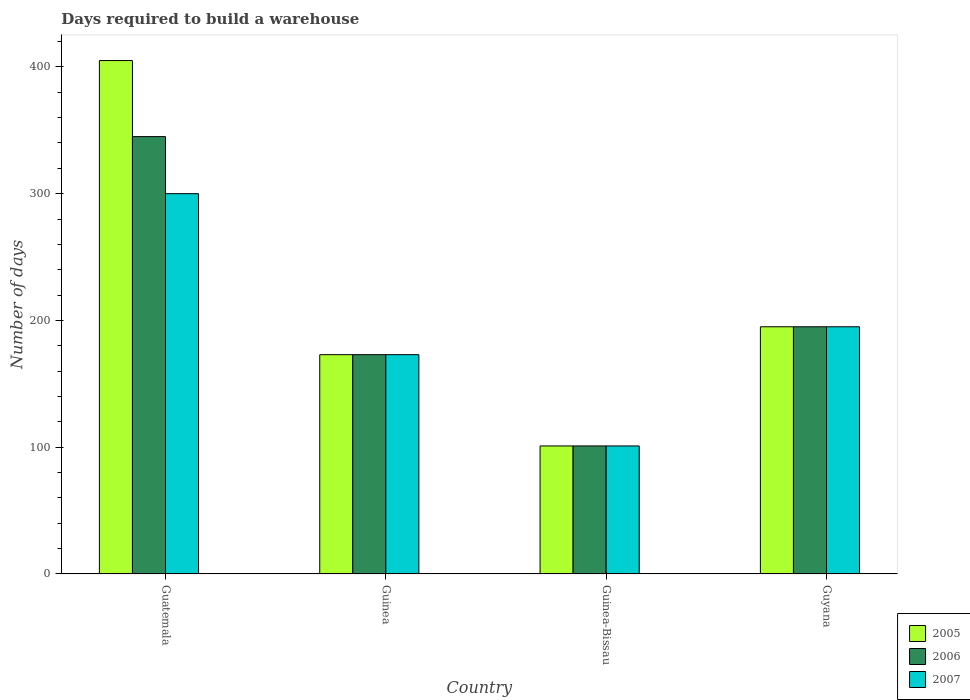How many groups of bars are there?
Keep it short and to the point. 4. Are the number of bars per tick equal to the number of legend labels?
Your answer should be very brief. Yes. Are the number of bars on each tick of the X-axis equal?
Keep it short and to the point. Yes. What is the label of the 3rd group of bars from the left?
Offer a very short reply. Guinea-Bissau. In how many cases, is the number of bars for a given country not equal to the number of legend labels?
Ensure brevity in your answer.  0. What is the days required to build a warehouse in in 2006 in Guinea-Bissau?
Make the answer very short. 101. Across all countries, what is the maximum days required to build a warehouse in in 2007?
Give a very brief answer. 300. Across all countries, what is the minimum days required to build a warehouse in in 2007?
Provide a succinct answer. 101. In which country was the days required to build a warehouse in in 2006 maximum?
Your response must be concise. Guatemala. In which country was the days required to build a warehouse in in 2005 minimum?
Give a very brief answer. Guinea-Bissau. What is the total days required to build a warehouse in in 2006 in the graph?
Offer a terse response. 814. What is the difference between the days required to build a warehouse in in 2005 in Guinea-Bissau and that in Guyana?
Provide a succinct answer. -94. What is the difference between the days required to build a warehouse in in 2007 in Guinea and the days required to build a warehouse in in 2005 in Guinea-Bissau?
Give a very brief answer. 72. What is the average days required to build a warehouse in in 2006 per country?
Provide a succinct answer. 203.5. What is the difference between the days required to build a warehouse in of/in 2006 and days required to build a warehouse in of/in 2007 in Guyana?
Make the answer very short. 0. In how many countries, is the days required to build a warehouse in in 2007 greater than 40 days?
Your answer should be very brief. 4. What is the ratio of the days required to build a warehouse in in 2005 in Guatemala to that in Guyana?
Give a very brief answer. 2.08. Is the days required to build a warehouse in in 2006 in Guatemala less than that in Guyana?
Give a very brief answer. No. What is the difference between the highest and the second highest days required to build a warehouse in in 2006?
Provide a short and direct response. 150. What is the difference between the highest and the lowest days required to build a warehouse in in 2006?
Make the answer very short. 244. Is it the case that in every country, the sum of the days required to build a warehouse in in 2007 and days required to build a warehouse in in 2005 is greater than the days required to build a warehouse in in 2006?
Provide a short and direct response. Yes. Are all the bars in the graph horizontal?
Ensure brevity in your answer.  No. How many countries are there in the graph?
Keep it short and to the point. 4. Where does the legend appear in the graph?
Your answer should be very brief. Bottom right. What is the title of the graph?
Your answer should be compact. Days required to build a warehouse. What is the label or title of the X-axis?
Your answer should be compact. Country. What is the label or title of the Y-axis?
Ensure brevity in your answer.  Number of days. What is the Number of days of 2005 in Guatemala?
Provide a short and direct response. 405. What is the Number of days of 2006 in Guatemala?
Provide a succinct answer. 345. What is the Number of days in 2007 in Guatemala?
Give a very brief answer. 300. What is the Number of days in 2005 in Guinea?
Make the answer very short. 173. What is the Number of days of 2006 in Guinea?
Provide a succinct answer. 173. What is the Number of days of 2007 in Guinea?
Keep it short and to the point. 173. What is the Number of days in 2005 in Guinea-Bissau?
Your response must be concise. 101. What is the Number of days in 2006 in Guinea-Bissau?
Your answer should be very brief. 101. What is the Number of days in 2007 in Guinea-Bissau?
Keep it short and to the point. 101. What is the Number of days in 2005 in Guyana?
Ensure brevity in your answer.  195. What is the Number of days in 2006 in Guyana?
Your answer should be compact. 195. What is the Number of days of 2007 in Guyana?
Your response must be concise. 195. Across all countries, what is the maximum Number of days in 2005?
Make the answer very short. 405. Across all countries, what is the maximum Number of days of 2006?
Make the answer very short. 345. Across all countries, what is the maximum Number of days of 2007?
Your answer should be very brief. 300. Across all countries, what is the minimum Number of days in 2005?
Give a very brief answer. 101. Across all countries, what is the minimum Number of days in 2006?
Your answer should be very brief. 101. Across all countries, what is the minimum Number of days of 2007?
Give a very brief answer. 101. What is the total Number of days of 2005 in the graph?
Give a very brief answer. 874. What is the total Number of days in 2006 in the graph?
Give a very brief answer. 814. What is the total Number of days of 2007 in the graph?
Offer a terse response. 769. What is the difference between the Number of days of 2005 in Guatemala and that in Guinea?
Keep it short and to the point. 232. What is the difference between the Number of days in 2006 in Guatemala and that in Guinea?
Give a very brief answer. 172. What is the difference between the Number of days of 2007 in Guatemala and that in Guinea?
Offer a terse response. 127. What is the difference between the Number of days of 2005 in Guatemala and that in Guinea-Bissau?
Offer a very short reply. 304. What is the difference between the Number of days in 2006 in Guatemala and that in Guinea-Bissau?
Your response must be concise. 244. What is the difference between the Number of days of 2007 in Guatemala and that in Guinea-Bissau?
Ensure brevity in your answer.  199. What is the difference between the Number of days in 2005 in Guatemala and that in Guyana?
Your response must be concise. 210. What is the difference between the Number of days in 2006 in Guatemala and that in Guyana?
Your answer should be very brief. 150. What is the difference between the Number of days in 2007 in Guatemala and that in Guyana?
Ensure brevity in your answer.  105. What is the difference between the Number of days in 2005 in Guinea and that in Guinea-Bissau?
Keep it short and to the point. 72. What is the difference between the Number of days of 2007 in Guinea and that in Guinea-Bissau?
Offer a very short reply. 72. What is the difference between the Number of days in 2005 in Guinea and that in Guyana?
Offer a very short reply. -22. What is the difference between the Number of days in 2005 in Guinea-Bissau and that in Guyana?
Provide a succinct answer. -94. What is the difference between the Number of days in 2006 in Guinea-Bissau and that in Guyana?
Give a very brief answer. -94. What is the difference between the Number of days in 2007 in Guinea-Bissau and that in Guyana?
Give a very brief answer. -94. What is the difference between the Number of days of 2005 in Guatemala and the Number of days of 2006 in Guinea?
Provide a short and direct response. 232. What is the difference between the Number of days of 2005 in Guatemala and the Number of days of 2007 in Guinea?
Your answer should be very brief. 232. What is the difference between the Number of days of 2006 in Guatemala and the Number of days of 2007 in Guinea?
Make the answer very short. 172. What is the difference between the Number of days in 2005 in Guatemala and the Number of days in 2006 in Guinea-Bissau?
Ensure brevity in your answer.  304. What is the difference between the Number of days of 2005 in Guatemala and the Number of days of 2007 in Guinea-Bissau?
Make the answer very short. 304. What is the difference between the Number of days in 2006 in Guatemala and the Number of days in 2007 in Guinea-Bissau?
Provide a short and direct response. 244. What is the difference between the Number of days of 2005 in Guatemala and the Number of days of 2006 in Guyana?
Give a very brief answer. 210. What is the difference between the Number of days in 2005 in Guatemala and the Number of days in 2007 in Guyana?
Provide a succinct answer. 210. What is the difference between the Number of days in 2006 in Guatemala and the Number of days in 2007 in Guyana?
Offer a terse response. 150. What is the difference between the Number of days of 2005 in Guinea and the Number of days of 2006 in Guinea-Bissau?
Offer a terse response. 72. What is the difference between the Number of days of 2005 in Guinea and the Number of days of 2007 in Guinea-Bissau?
Make the answer very short. 72. What is the difference between the Number of days in 2005 in Guinea and the Number of days in 2006 in Guyana?
Provide a short and direct response. -22. What is the difference between the Number of days of 2005 in Guinea-Bissau and the Number of days of 2006 in Guyana?
Make the answer very short. -94. What is the difference between the Number of days of 2005 in Guinea-Bissau and the Number of days of 2007 in Guyana?
Offer a very short reply. -94. What is the difference between the Number of days of 2006 in Guinea-Bissau and the Number of days of 2007 in Guyana?
Offer a terse response. -94. What is the average Number of days in 2005 per country?
Make the answer very short. 218.5. What is the average Number of days in 2006 per country?
Offer a very short reply. 203.5. What is the average Number of days in 2007 per country?
Give a very brief answer. 192.25. What is the difference between the Number of days of 2005 and Number of days of 2007 in Guatemala?
Provide a succinct answer. 105. What is the difference between the Number of days of 2006 and Number of days of 2007 in Guinea?
Offer a very short reply. 0. What is the difference between the Number of days in 2005 and Number of days in 2007 in Guinea-Bissau?
Provide a succinct answer. 0. What is the difference between the Number of days of 2006 and Number of days of 2007 in Guinea-Bissau?
Offer a terse response. 0. What is the ratio of the Number of days in 2005 in Guatemala to that in Guinea?
Provide a succinct answer. 2.34. What is the ratio of the Number of days in 2006 in Guatemala to that in Guinea?
Your response must be concise. 1.99. What is the ratio of the Number of days in 2007 in Guatemala to that in Guinea?
Ensure brevity in your answer.  1.73. What is the ratio of the Number of days in 2005 in Guatemala to that in Guinea-Bissau?
Give a very brief answer. 4.01. What is the ratio of the Number of days of 2006 in Guatemala to that in Guinea-Bissau?
Your response must be concise. 3.42. What is the ratio of the Number of days of 2007 in Guatemala to that in Guinea-Bissau?
Make the answer very short. 2.97. What is the ratio of the Number of days of 2005 in Guatemala to that in Guyana?
Give a very brief answer. 2.08. What is the ratio of the Number of days in 2006 in Guatemala to that in Guyana?
Provide a short and direct response. 1.77. What is the ratio of the Number of days in 2007 in Guatemala to that in Guyana?
Offer a terse response. 1.54. What is the ratio of the Number of days of 2005 in Guinea to that in Guinea-Bissau?
Provide a succinct answer. 1.71. What is the ratio of the Number of days of 2006 in Guinea to that in Guinea-Bissau?
Your answer should be compact. 1.71. What is the ratio of the Number of days of 2007 in Guinea to that in Guinea-Bissau?
Offer a terse response. 1.71. What is the ratio of the Number of days in 2005 in Guinea to that in Guyana?
Give a very brief answer. 0.89. What is the ratio of the Number of days in 2006 in Guinea to that in Guyana?
Your answer should be compact. 0.89. What is the ratio of the Number of days of 2007 in Guinea to that in Guyana?
Ensure brevity in your answer.  0.89. What is the ratio of the Number of days in 2005 in Guinea-Bissau to that in Guyana?
Your answer should be compact. 0.52. What is the ratio of the Number of days in 2006 in Guinea-Bissau to that in Guyana?
Provide a succinct answer. 0.52. What is the ratio of the Number of days in 2007 in Guinea-Bissau to that in Guyana?
Provide a succinct answer. 0.52. What is the difference between the highest and the second highest Number of days of 2005?
Offer a very short reply. 210. What is the difference between the highest and the second highest Number of days in 2006?
Offer a terse response. 150. What is the difference between the highest and the second highest Number of days of 2007?
Offer a terse response. 105. What is the difference between the highest and the lowest Number of days of 2005?
Offer a terse response. 304. What is the difference between the highest and the lowest Number of days of 2006?
Offer a terse response. 244. What is the difference between the highest and the lowest Number of days in 2007?
Provide a succinct answer. 199. 